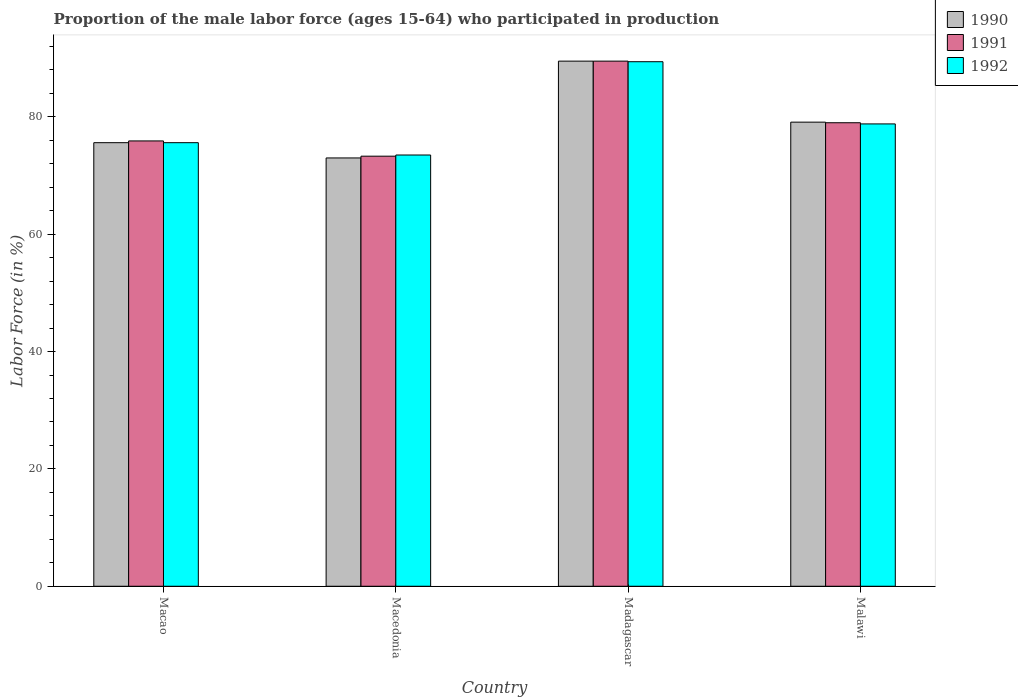How many different coloured bars are there?
Ensure brevity in your answer.  3. How many groups of bars are there?
Provide a short and direct response. 4. Are the number of bars per tick equal to the number of legend labels?
Provide a short and direct response. Yes. Are the number of bars on each tick of the X-axis equal?
Your answer should be very brief. Yes. How many bars are there on the 4th tick from the right?
Your answer should be very brief. 3. What is the label of the 3rd group of bars from the left?
Offer a very short reply. Madagascar. In how many cases, is the number of bars for a given country not equal to the number of legend labels?
Provide a short and direct response. 0. What is the proportion of the male labor force who participated in production in 1991 in Macedonia?
Offer a terse response. 73.3. Across all countries, what is the maximum proportion of the male labor force who participated in production in 1992?
Offer a very short reply. 89.4. Across all countries, what is the minimum proportion of the male labor force who participated in production in 1991?
Provide a short and direct response. 73.3. In which country was the proportion of the male labor force who participated in production in 1991 maximum?
Offer a terse response. Madagascar. In which country was the proportion of the male labor force who participated in production in 1992 minimum?
Keep it short and to the point. Macedonia. What is the total proportion of the male labor force who participated in production in 1990 in the graph?
Provide a succinct answer. 317.2. What is the difference between the proportion of the male labor force who participated in production in 1992 in Macedonia and that in Malawi?
Your answer should be very brief. -5.3. What is the difference between the proportion of the male labor force who participated in production in 1992 in Madagascar and the proportion of the male labor force who participated in production in 1990 in Macedonia?
Keep it short and to the point. 16.4. What is the average proportion of the male labor force who participated in production in 1991 per country?
Offer a very short reply. 79.43. What is the difference between the proportion of the male labor force who participated in production of/in 1992 and proportion of the male labor force who participated in production of/in 1991 in Macedonia?
Ensure brevity in your answer.  0.2. What is the ratio of the proportion of the male labor force who participated in production in 1992 in Macedonia to that in Malawi?
Give a very brief answer. 0.93. Is the proportion of the male labor force who participated in production in 1992 in Macao less than that in Macedonia?
Ensure brevity in your answer.  No. Is the difference between the proportion of the male labor force who participated in production in 1992 in Macedonia and Madagascar greater than the difference between the proportion of the male labor force who participated in production in 1991 in Macedonia and Madagascar?
Your answer should be very brief. Yes. What is the difference between the highest and the second highest proportion of the male labor force who participated in production in 1992?
Provide a short and direct response. 13.8. What is the difference between the highest and the lowest proportion of the male labor force who participated in production in 1992?
Your answer should be compact. 15.9. In how many countries, is the proportion of the male labor force who participated in production in 1992 greater than the average proportion of the male labor force who participated in production in 1992 taken over all countries?
Keep it short and to the point. 1. What does the 3rd bar from the right in Macedonia represents?
Provide a succinct answer. 1990. Is it the case that in every country, the sum of the proportion of the male labor force who participated in production in 1992 and proportion of the male labor force who participated in production in 1990 is greater than the proportion of the male labor force who participated in production in 1991?
Offer a very short reply. Yes. How many bars are there?
Your response must be concise. 12. Are all the bars in the graph horizontal?
Your response must be concise. No. How many countries are there in the graph?
Provide a succinct answer. 4. How many legend labels are there?
Give a very brief answer. 3. How are the legend labels stacked?
Offer a very short reply. Vertical. What is the title of the graph?
Offer a very short reply. Proportion of the male labor force (ages 15-64) who participated in production. What is the label or title of the Y-axis?
Provide a succinct answer. Labor Force (in %). What is the Labor Force (in %) of 1990 in Macao?
Provide a short and direct response. 75.6. What is the Labor Force (in %) in 1991 in Macao?
Provide a short and direct response. 75.9. What is the Labor Force (in %) in 1992 in Macao?
Your answer should be compact. 75.6. What is the Labor Force (in %) in 1991 in Macedonia?
Your response must be concise. 73.3. What is the Labor Force (in %) in 1992 in Macedonia?
Give a very brief answer. 73.5. What is the Labor Force (in %) of 1990 in Madagascar?
Your response must be concise. 89.5. What is the Labor Force (in %) of 1991 in Madagascar?
Offer a very short reply. 89.5. What is the Labor Force (in %) in 1992 in Madagascar?
Ensure brevity in your answer.  89.4. What is the Labor Force (in %) of 1990 in Malawi?
Your answer should be very brief. 79.1. What is the Labor Force (in %) of 1991 in Malawi?
Provide a succinct answer. 79. What is the Labor Force (in %) of 1992 in Malawi?
Your answer should be very brief. 78.8. Across all countries, what is the maximum Labor Force (in %) of 1990?
Offer a very short reply. 89.5. Across all countries, what is the maximum Labor Force (in %) of 1991?
Ensure brevity in your answer.  89.5. Across all countries, what is the maximum Labor Force (in %) of 1992?
Provide a succinct answer. 89.4. Across all countries, what is the minimum Labor Force (in %) in 1990?
Offer a very short reply. 73. Across all countries, what is the minimum Labor Force (in %) of 1991?
Provide a short and direct response. 73.3. Across all countries, what is the minimum Labor Force (in %) in 1992?
Make the answer very short. 73.5. What is the total Labor Force (in %) in 1990 in the graph?
Your answer should be very brief. 317.2. What is the total Labor Force (in %) in 1991 in the graph?
Provide a short and direct response. 317.7. What is the total Labor Force (in %) of 1992 in the graph?
Make the answer very short. 317.3. What is the difference between the Labor Force (in %) in 1991 in Macao and that in Macedonia?
Offer a very short reply. 2.6. What is the difference between the Labor Force (in %) in 1992 in Macao and that in Macedonia?
Your answer should be compact. 2.1. What is the difference between the Labor Force (in %) of 1990 in Macao and that in Madagascar?
Your answer should be compact. -13.9. What is the difference between the Labor Force (in %) of 1992 in Macao and that in Madagascar?
Your response must be concise. -13.8. What is the difference between the Labor Force (in %) of 1992 in Macao and that in Malawi?
Offer a terse response. -3.2. What is the difference between the Labor Force (in %) in 1990 in Macedonia and that in Madagascar?
Your answer should be compact. -16.5. What is the difference between the Labor Force (in %) of 1991 in Macedonia and that in Madagascar?
Offer a terse response. -16.2. What is the difference between the Labor Force (in %) of 1992 in Macedonia and that in Madagascar?
Your response must be concise. -15.9. What is the difference between the Labor Force (in %) of 1990 in Macedonia and that in Malawi?
Offer a terse response. -6.1. What is the difference between the Labor Force (in %) in 1990 in Madagascar and that in Malawi?
Provide a short and direct response. 10.4. What is the difference between the Labor Force (in %) in 1992 in Madagascar and that in Malawi?
Provide a succinct answer. 10.6. What is the difference between the Labor Force (in %) of 1991 in Macao and the Labor Force (in %) of 1992 in Macedonia?
Your response must be concise. 2.4. What is the difference between the Labor Force (in %) in 1990 in Macao and the Labor Force (in %) in 1992 in Madagascar?
Your response must be concise. -13.8. What is the difference between the Labor Force (in %) in 1990 in Macao and the Labor Force (in %) in 1992 in Malawi?
Give a very brief answer. -3.2. What is the difference between the Labor Force (in %) of 1991 in Macao and the Labor Force (in %) of 1992 in Malawi?
Your response must be concise. -2.9. What is the difference between the Labor Force (in %) in 1990 in Macedonia and the Labor Force (in %) in 1991 in Madagascar?
Your answer should be very brief. -16.5. What is the difference between the Labor Force (in %) in 1990 in Macedonia and the Labor Force (in %) in 1992 in Madagascar?
Make the answer very short. -16.4. What is the difference between the Labor Force (in %) in 1991 in Macedonia and the Labor Force (in %) in 1992 in Madagascar?
Make the answer very short. -16.1. What is the difference between the Labor Force (in %) of 1990 in Macedonia and the Labor Force (in %) of 1992 in Malawi?
Provide a short and direct response. -5.8. What is the difference between the Labor Force (in %) in 1991 in Madagascar and the Labor Force (in %) in 1992 in Malawi?
Your answer should be very brief. 10.7. What is the average Labor Force (in %) of 1990 per country?
Offer a terse response. 79.3. What is the average Labor Force (in %) in 1991 per country?
Provide a succinct answer. 79.42. What is the average Labor Force (in %) in 1992 per country?
Give a very brief answer. 79.33. What is the difference between the Labor Force (in %) of 1990 and Labor Force (in %) of 1991 in Macao?
Your answer should be very brief. -0.3. What is the difference between the Labor Force (in %) of 1990 and Labor Force (in %) of 1992 in Macao?
Offer a very short reply. 0. What is the difference between the Labor Force (in %) of 1990 and Labor Force (in %) of 1991 in Macedonia?
Ensure brevity in your answer.  -0.3. What is the difference between the Labor Force (in %) in 1991 and Labor Force (in %) in 1992 in Macedonia?
Provide a succinct answer. -0.2. What is the difference between the Labor Force (in %) of 1990 and Labor Force (in %) of 1991 in Madagascar?
Keep it short and to the point. 0. What is the difference between the Labor Force (in %) in 1990 and Labor Force (in %) in 1992 in Madagascar?
Provide a short and direct response. 0.1. What is the difference between the Labor Force (in %) in 1991 and Labor Force (in %) in 1992 in Madagascar?
Ensure brevity in your answer.  0.1. What is the difference between the Labor Force (in %) of 1991 and Labor Force (in %) of 1992 in Malawi?
Your answer should be compact. 0.2. What is the ratio of the Labor Force (in %) in 1990 in Macao to that in Macedonia?
Provide a succinct answer. 1.04. What is the ratio of the Labor Force (in %) in 1991 in Macao to that in Macedonia?
Keep it short and to the point. 1.04. What is the ratio of the Labor Force (in %) in 1992 in Macao to that in Macedonia?
Make the answer very short. 1.03. What is the ratio of the Labor Force (in %) in 1990 in Macao to that in Madagascar?
Ensure brevity in your answer.  0.84. What is the ratio of the Labor Force (in %) in 1991 in Macao to that in Madagascar?
Make the answer very short. 0.85. What is the ratio of the Labor Force (in %) in 1992 in Macao to that in Madagascar?
Ensure brevity in your answer.  0.85. What is the ratio of the Labor Force (in %) of 1990 in Macao to that in Malawi?
Offer a very short reply. 0.96. What is the ratio of the Labor Force (in %) of 1991 in Macao to that in Malawi?
Offer a terse response. 0.96. What is the ratio of the Labor Force (in %) of 1992 in Macao to that in Malawi?
Keep it short and to the point. 0.96. What is the ratio of the Labor Force (in %) of 1990 in Macedonia to that in Madagascar?
Your answer should be very brief. 0.82. What is the ratio of the Labor Force (in %) of 1991 in Macedonia to that in Madagascar?
Provide a succinct answer. 0.82. What is the ratio of the Labor Force (in %) of 1992 in Macedonia to that in Madagascar?
Provide a succinct answer. 0.82. What is the ratio of the Labor Force (in %) in 1990 in Macedonia to that in Malawi?
Your response must be concise. 0.92. What is the ratio of the Labor Force (in %) of 1991 in Macedonia to that in Malawi?
Your response must be concise. 0.93. What is the ratio of the Labor Force (in %) of 1992 in Macedonia to that in Malawi?
Offer a very short reply. 0.93. What is the ratio of the Labor Force (in %) in 1990 in Madagascar to that in Malawi?
Give a very brief answer. 1.13. What is the ratio of the Labor Force (in %) in 1991 in Madagascar to that in Malawi?
Give a very brief answer. 1.13. What is the ratio of the Labor Force (in %) in 1992 in Madagascar to that in Malawi?
Make the answer very short. 1.13. What is the difference between the highest and the second highest Labor Force (in %) of 1991?
Ensure brevity in your answer.  10.5. What is the difference between the highest and the second highest Labor Force (in %) in 1992?
Offer a very short reply. 10.6. What is the difference between the highest and the lowest Labor Force (in %) in 1990?
Keep it short and to the point. 16.5. What is the difference between the highest and the lowest Labor Force (in %) in 1991?
Provide a short and direct response. 16.2. 